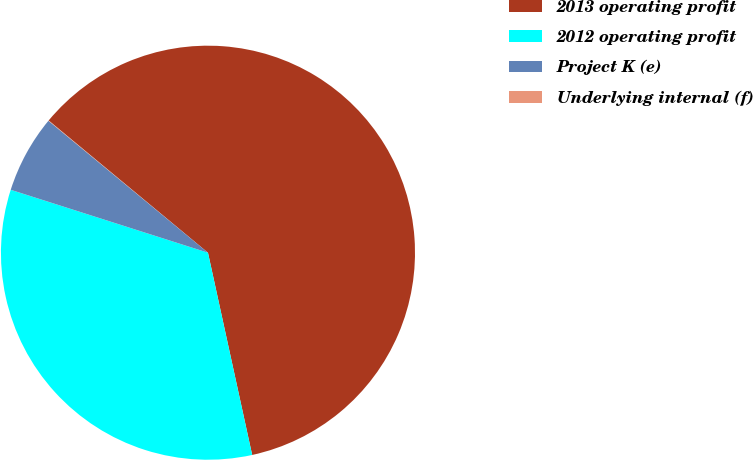Convert chart. <chart><loc_0><loc_0><loc_500><loc_500><pie_chart><fcel>2013 operating profit<fcel>2012 operating profit<fcel>Project K (e)<fcel>Underlying internal (f)<nl><fcel>60.55%<fcel>33.34%<fcel>6.08%<fcel>0.03%<nl></chart> 